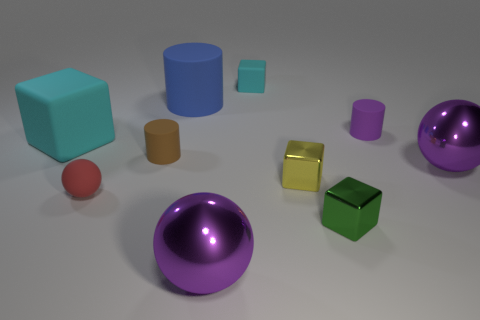Is the small matte block the same color as the big matte cube?
Give a very brief answer. Yes. The tiny rubber thing that is to the right of the small green metallic thing in front of the tiny matte ball is what shape?
Your answer should be compact. Cylinder. Is the material of the large thing that is behind the large cyan cube the same as the small yellow object?
Keep it short and to the point. No. Are there an equal number of objects that are on the right side of the small brown rubber cylinder and objects behind the tiny red object?
Offer a very short reply. Yes. There is another block that is the same color as the large cube; what material is it?
Your answer should be compact. Rubber. There is a large metal ball behind the green metal block; how many big cubes are on the right side of it?
Ensure brevity in your answer.  0. Does the thing that is on the left side of the rubber sphere have the same color as the matte cube on the right side of the red matte thing?
Make the answer very short. Yes. There is a brown object that is the same size as the red rubber object; what is its material?
Your response must be concise. Rubber. What shape is the matte thing that is in front of the tiny brown matte object that is behind the purple metallic ball behind the tiny yellow cube?
Your response must be concise. Sphere. What is the shape of the red thing that is the same size as the green metal block?
Ensure brevity in your answer.  Sphere. 